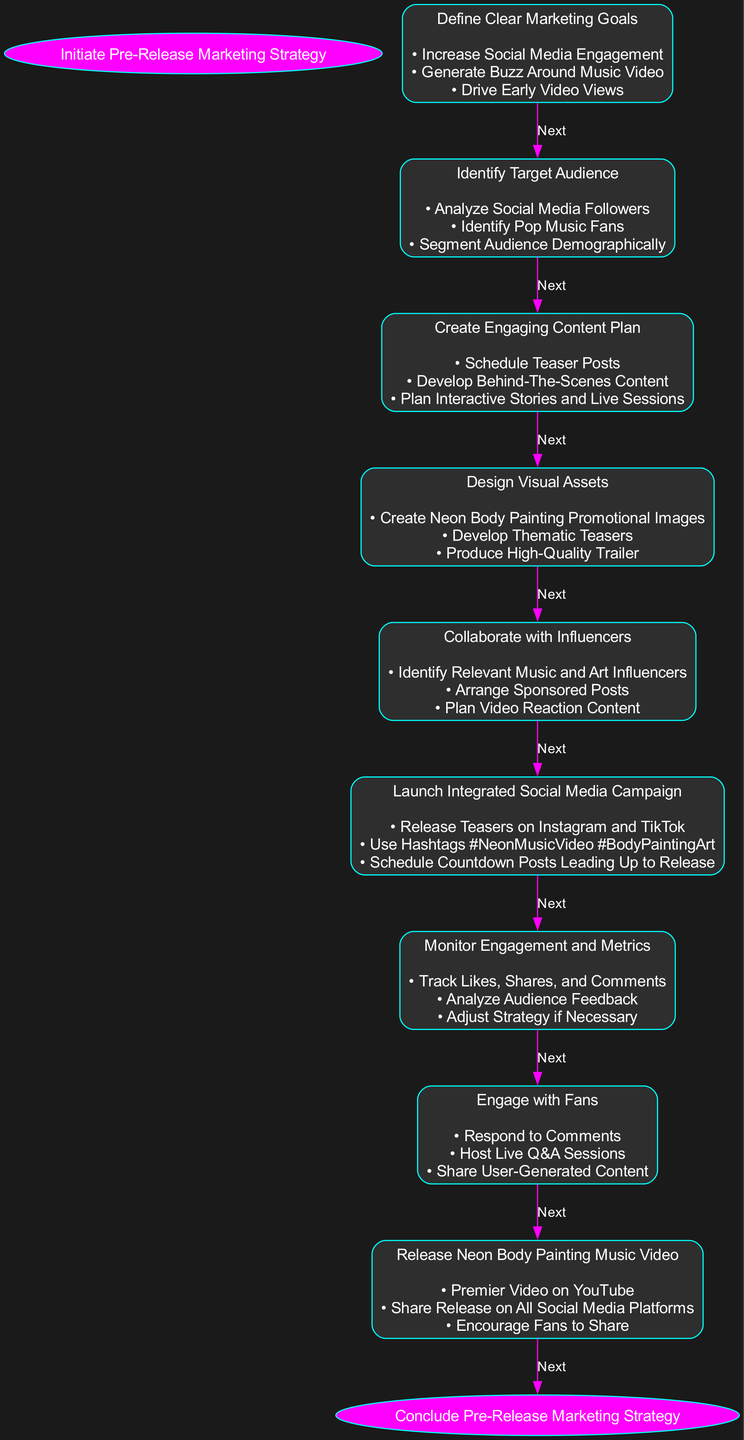What is the first step in the pre-release marketing strategy? The first step in the flowchart, labeled as "Start," indicates the initiation of the pre-release marketing strategy.
Answer: Initiate Pre-Release Marketing Strategy How many main steps are there before releasing the music video? By counting the nodes from "Define Goals" to "Release Music Video," we find that there are six main steps in the process.
Answer: Six What is the action associated with the "Create Engaging Content Plan" step? This step is about creating a content plan, and the actions listed include scheduling teaser posts, developing behind-the-scenes content, and planning interactive stories and live sessions.
Answer: Schedule Teaser Posts What comes after "Monitor Engagement and Metrics"? After the "Monitor Engagement and Metrics" step, the next action is to "Respond to Fans" according to the flowchart.
Answer: Respond to Fans Which node focuses on collaboration with influencers? The flowchart specifically mentions "Collaborate with Influencers," which is the node that outlines actions related to influencer engagement.
Answer: Collaborate with Influencers How is social media engagement monitored in the strategy? The monitoring is detailed in the “Monitor Engagement and Metrics” step, which includes actions like tracking likes, shares, comments, and analyzing audience feedback.
Answer: Track Likes, Shares, and Comments Which hashtags are recommended for the social media campaign? The planned hashtags for the campaign are "#NeonMusicVideo" and "#BodyPaintingArt," as mentioned under the "Launch Integrated Social Media Campaign."
Answer: Neon Music Video, Body Painting Art What is the final step in this marketing strategy flowchart? The last step in the flowchart is labeled as "End," concluding the pre-release marketing strategy process.
Answer: Conclude Pre-Release Marketing Strategy 